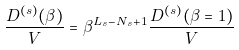<formula> <loc_0><loc_0><loc_500><loc_500>\frac { D ^ { ( s ) } ( \beta ) } { V } = \beta ^ { L _ { s } - N _ { s } + 1 } \frac { D ^ { ( s ) } ( \beta = 1 ) } { V }</formula> 